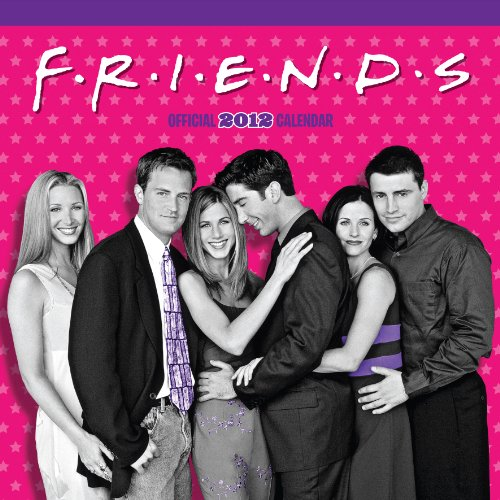Can you explain why this calendar might appeal to fans of 'Friends'? Fans of 'Friends' would find this calendar appealing as it features photographs and iconic scenes from the show, celebrating its memorable characters and moments. This serves as a daily reminder of their favorite episodes and can evoke fond memories of watching the series. 